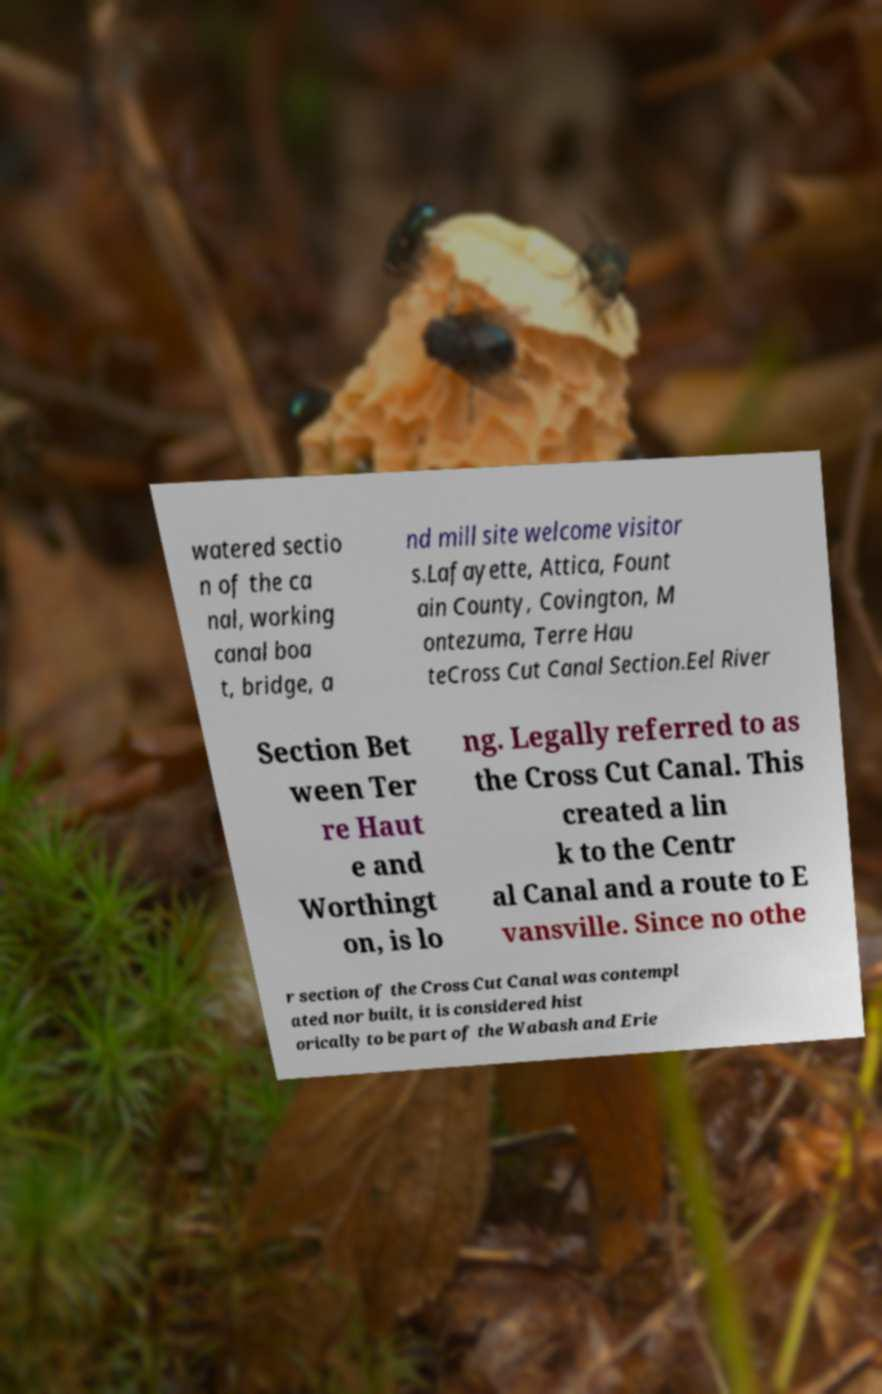What messages or text are displayed in this image? I need them in a readable, typed format. watered sectio n of the ca nal, working canal boa t, bridge, a nd mill site welcome visitor s.Lafayette, Attica, Fount ain County, Covington, M ontezuma, Terre Hau teCross Cut Canal Section.Eel River Section Bet ween Ter re Haut e and Worthingt on, is lo ng. Legally referred to as the Cross Cut Canal. This created a lin k to the Centr al Canal and a route to E vansville. Since no othe r section of the Cross Cut Canal was contempl ated nor built, it is considered hist orically to be part of the Wabash and Erie 